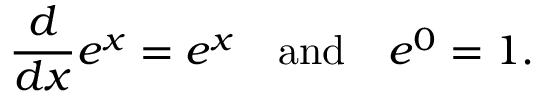Convert formula to latex. <formula><loc_0><loc_0><loc_500><loc_500>{ \frac { d } { d x } } e ^ { x } = e ^ { x } \quad a n d \quad e ^ { 0 } = 1 .</formula> 